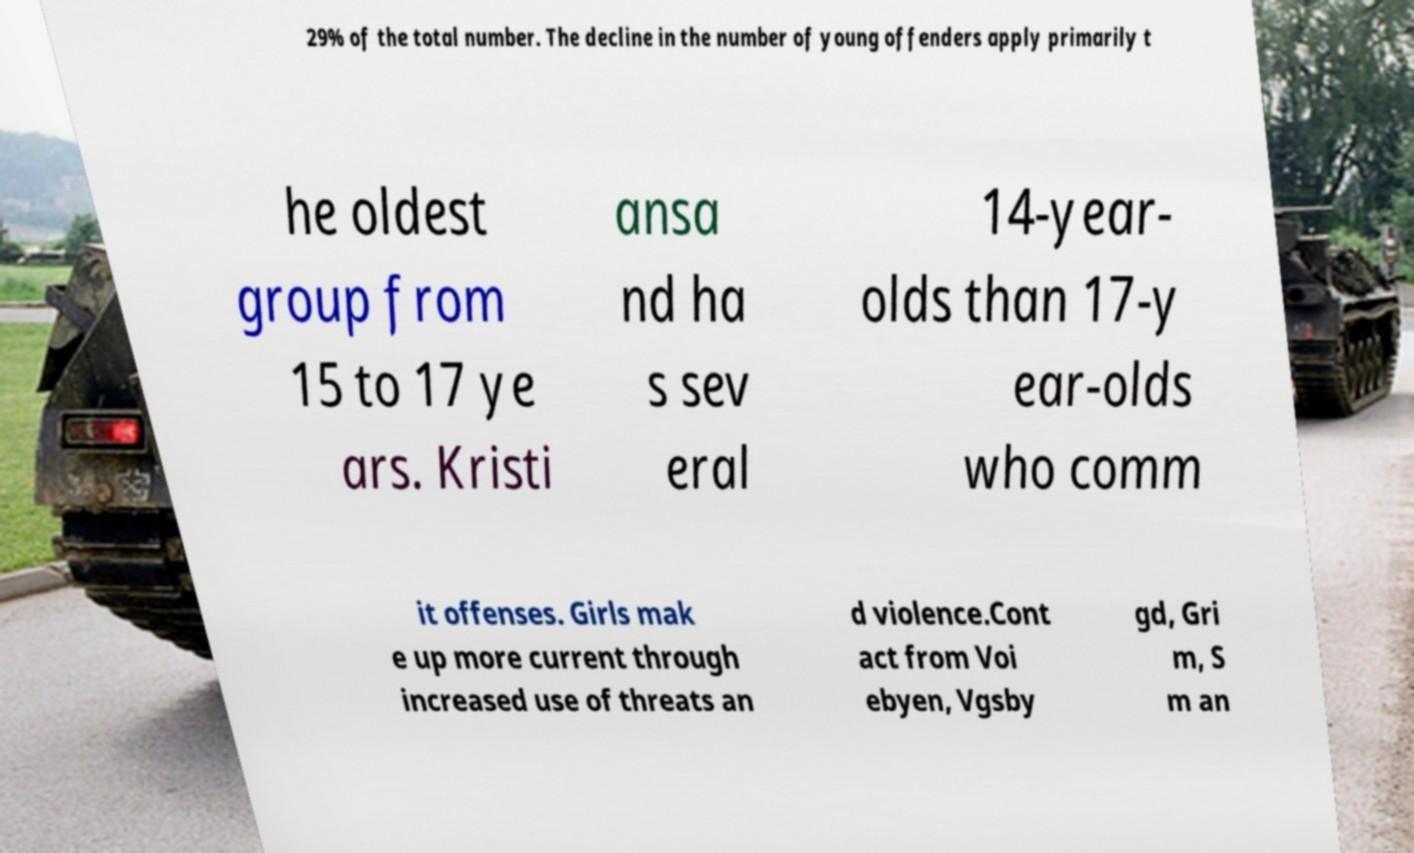For documentation purposes, I need the text within this image transcribed. Could you provide that? 29% of the total number. The decline in the number of young offenders apply primarily t he oldest group from 15 to 17 ye ars. Kristi ansa nd ha s sev eral 14-year- olds than 17-y ear-olds who comm it offenses. Girls mak e up more current through increased use of threats an d violence.Cont act from Voi ebyen, Vgsby gd, Gri m, S m an 